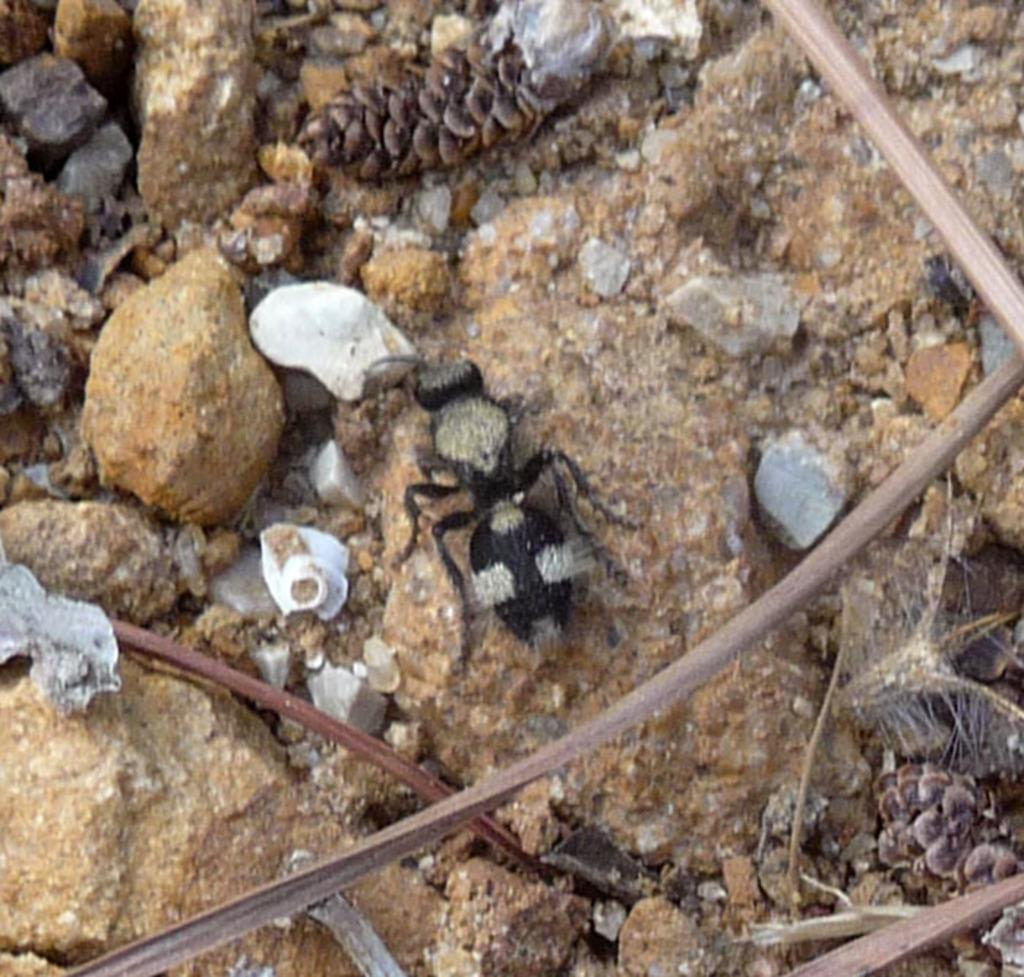What type of creature can be seen on the ground in the image? There is an insect on the ground in the image. What other objects can be seen on the ground in the image? Stones are visible in the image. What type of plant material is present in the image? Dried stems are present in the image. What grade is the son in the image? There is no son present in the image, so it is not possible to determine his grade. 